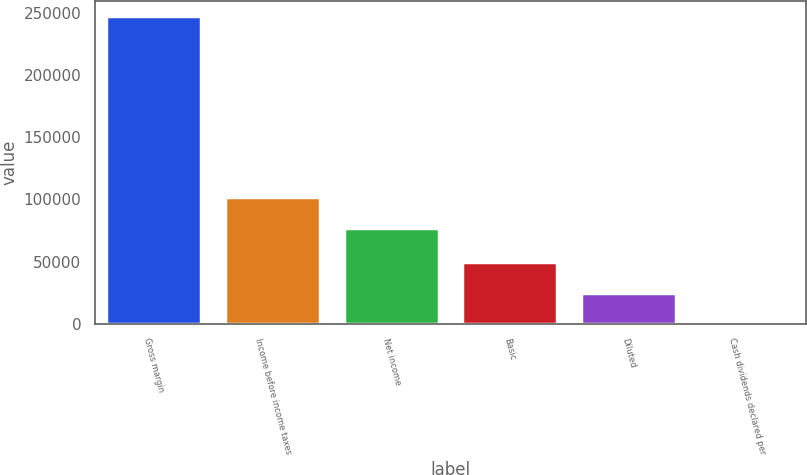Convert chart to OTSL. <chart><loc_0><loc_0><loc_500><loc_500><bar_chart><fcel>Gross margin<fcel>Income before income taxes<fcel>Net income<fcel>Basic<fcel>Diluted<fcel>Cash dividends declared per<nl><fcel>246897<fcel>101531<fcel>76841<fcel>49379.4<fcel>24689.8<fcel>0.07<nl></chart> 